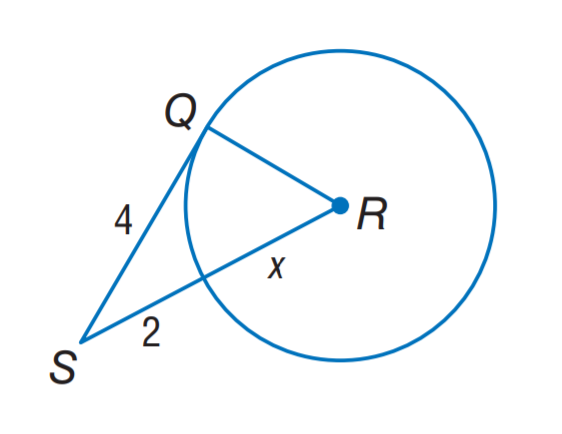Answer the mathemtical geometry problem and directly provide the correct option letter.
Question: Assume that the segment is tangent, find the value of x.
Choices: A: 2 B: 3 C: 4 D: 5 B 